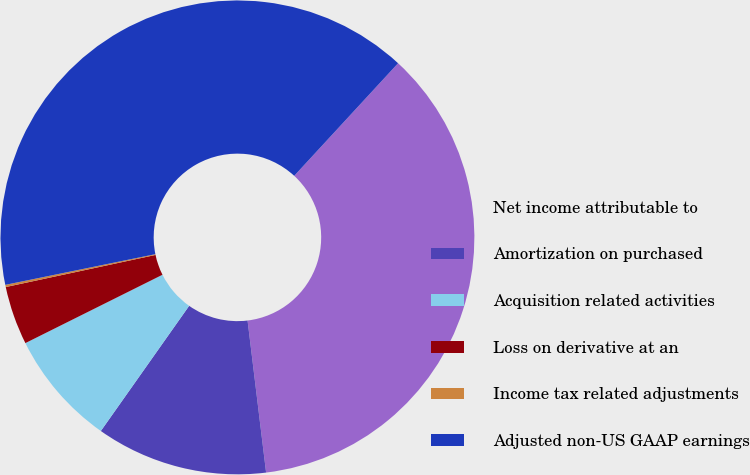Convert chart to OTSL. <chart><loc_0><loc_0><loc_500><loc_500><pie_chart><fcel>Net income attributable to<fcel>Amortization on purchased<fcel>Acquisition related activities<fcel>Loss on derivative at an<fcel>Income tax related adjustments<fcel>Adjusted non-US GAAP earnings<nl><fcel>36.21%<fcel>11.71%<fcel>7.86%<fcel>4.0%<fcel>0.15%<fcel>40.07%<nl></chart> 